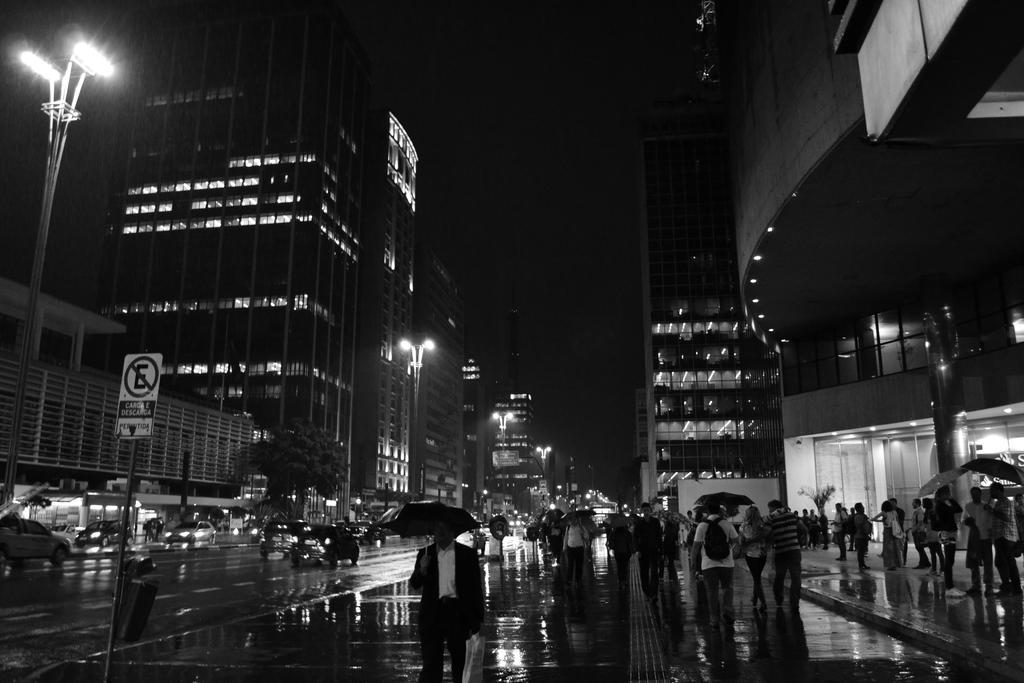In one or two sentences, can you explain what this image depicts? In the picture I can see people walking on the ground, among them some are holding umbrellas in hands. In the background I can see buildings, the sky, street lights, a sign board and some other objects. This picture is black and white in color. 